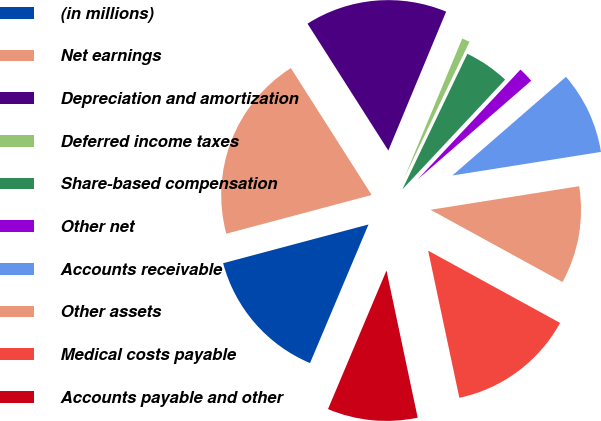Convert chart. <chart><loc_0><loc_0><loc_500><loc_500><pie_chart><fcel>(in millions)<fcel>Net earnings<fcel>Depreciation and amortization<fcel>Deferred income taxes<fcel>Share-based compensation<fcel>Other net<fcel>Accounts receivable<fcel>Other assets<fcel>Medical costs payable<fcel>Accounts payable and other<nl><fcel>14.5%<fcel>20.12%<fcel>15.3%<fcel>0.84%<fcel>4.86%<fcel>1.64%<fcel>8.88%<fcel>10.48%<fcel>13.7%<fcel>9.68%<nl></chart> 